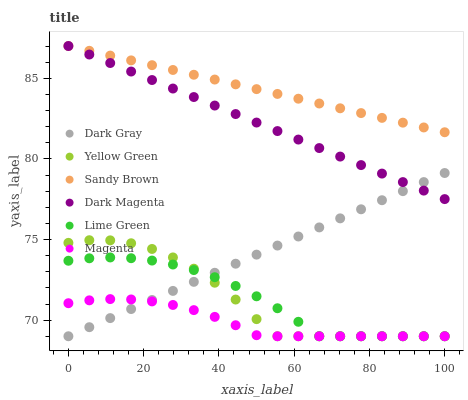Does Magenta have the minimum area under the curve?
Answer yes or no. Yes. Does Sandy Brown have the maximum area under the curve?
Answer yes or no. Yes. Does Dark Gray have the minimum area under the curve?
Answer yes or no. No. Does Dark Gray have the maximum area under the curve?
Answer yes or no. No. Is Dark Gray the smoothest?
Answer yes or no. Yes. Is Yellow Green the roughest?
Answer yes or no. Yes. Is Sandy Brown the smoothest?
Answer yes or no. No. Is Sandy Brown the roughest?
Answer yes or no. No. Does Yellow Green have the lowest value?
Answer yes or no. Yes. Does Sandy Brown have the lowest value?
Answer yes or no. No. Does Dark Magenta have the highest value?
Answer yes or no. Yes. Does Dark Gray have the highest value?
Answer yes or no. No. Is Lime Green less than Dark Magenta?
Answer yes or no. Yes. Is Sandy Brown greater than Lime Green?
Answer yes or no. Yes. Does Lime Green intersect Yellow Green?
Answer yes or no. Yes. Is Lime Green less than Yellow Green?
Answer yes or no. No. Is Lime Green greater than Yellow Green?
Answer yes or no. No. Does Lime Green intersect Dark Magenta?
Answer yes or no. No. 